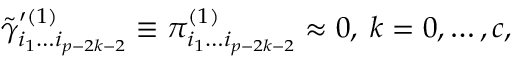Convert formula to latex. <formula><loc_0><loc_0><loc_500><loc_500>\tilde { \gamma } _ { i _ { 1 } \dots i _ { p - 2 k - 2 } } ^ { \prime ( 1 ) } \equiv \pi _ { i _ { 1 } \dots i _ { p - 2 k - 2 } } ^ { ( 1 ) } \approx 0 , \, k = 0 , \dots , c ,</formula> 